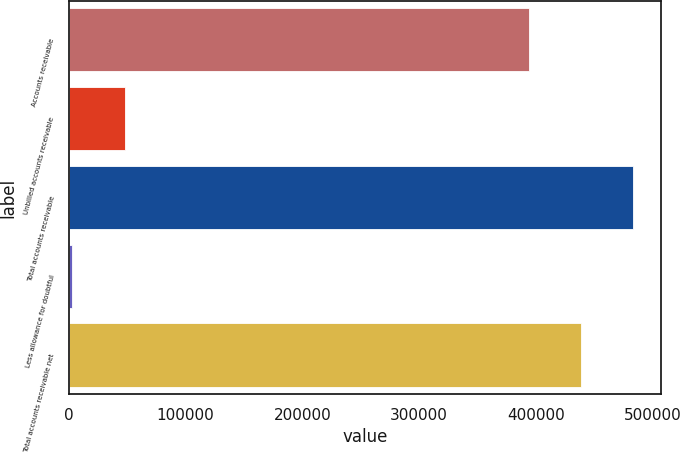<chart> <loc_0><loc_0><loc_500><loc_500><bar_chart><fcel>Accounts receivable<fcel>Unbilled accounts receivable<fcel>Total accounts receivable<fcel>Less allowance for doubtful<fcel>Total accounts receivable net<nl><fcel>394314<fcel>47760<fcel>482760<fcel>3201<fcel>438873<nl></chart> 